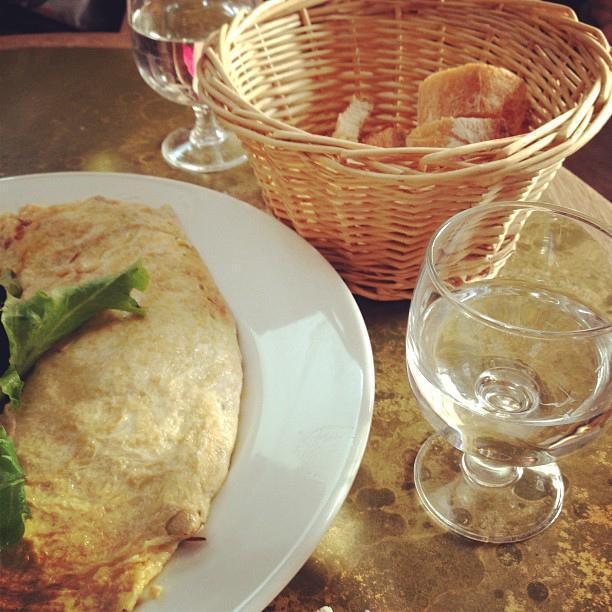How many wine glasses can be seen?
Give a very brief answer. 2. 